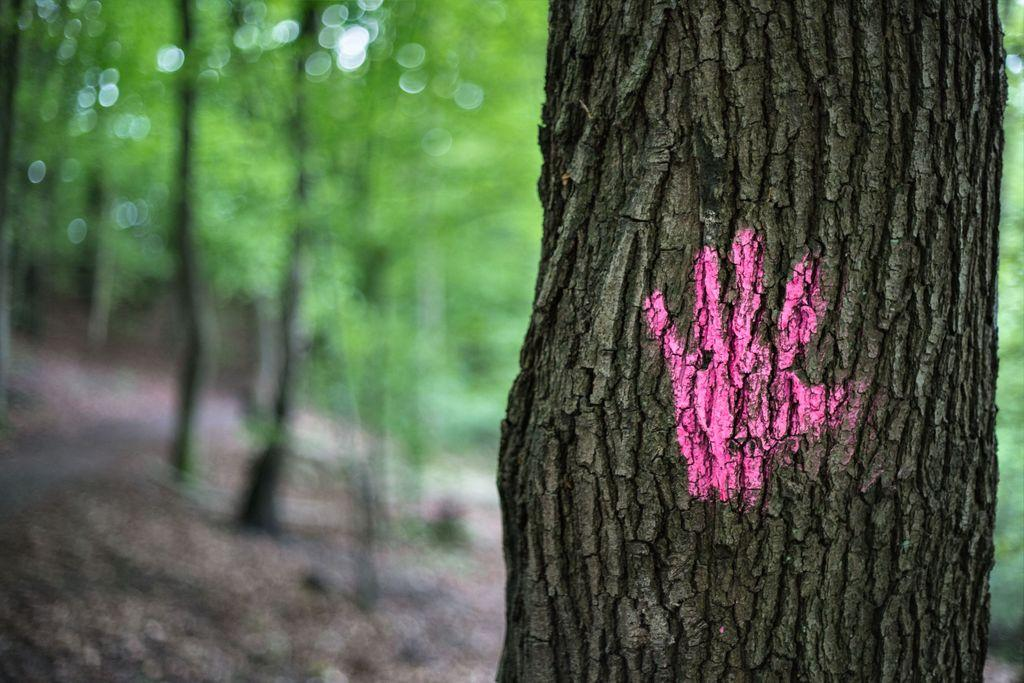What is the main subject in the image? There is a tree trunk in the image. What is touching the tree trunk? A person's hand is on the tree trunk. How can we describe the person's hand in the image? The person's hand is colored. What else can be seen in the image besides the tree trunk and the hand? There are trees in the image. Can you describe the background of the image? The background of the image is blurred. What type of reaction is the person having to the hot environment in the image? There is no indication of a hot environment or any reaction in the image. The person's hand is simply touching the tree trunk, and the background is blurred. 